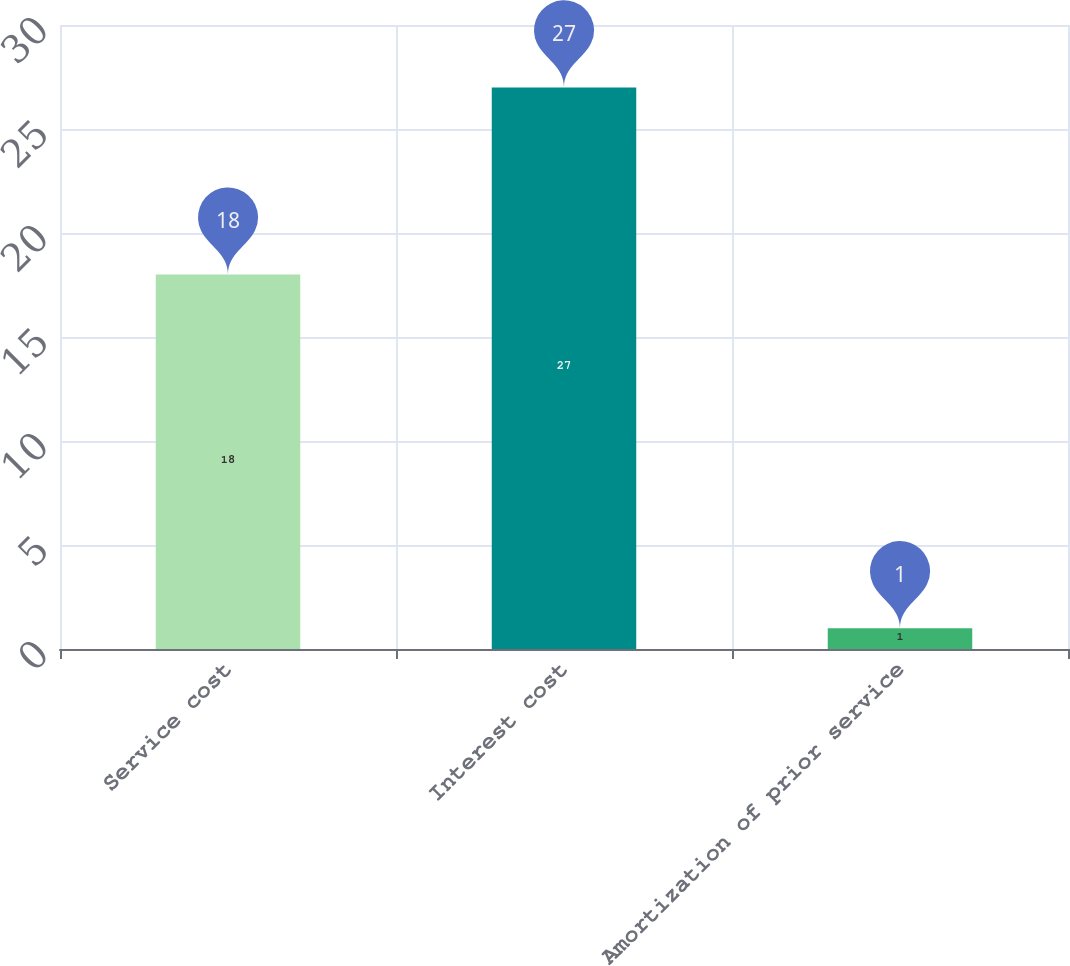Convert chart. <chart><loc_0><loc_0><loc_500><loc_500><bar_chart><fcel>Service cost<fcel>Interest cost<fcel>Amortization of prior service<nl><fcel>18<fcel>27<fcel>1<nl></chart> 